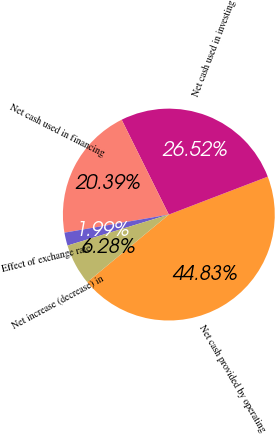<chart> <loc_0><loc_0><loc_500><loc_500><pie_chart><fcel>Net cash provided by operating<fcel>Net cash used in investing<fcel>Net cash used in financing<fcel>Effect of exchange rate<fcel>Net increase (decrease) in<nl><fcel>44.83%<fcel>26.52%<fcel>20.39%<fcel>1.99%<fcel>6.28%<nl></chart> 